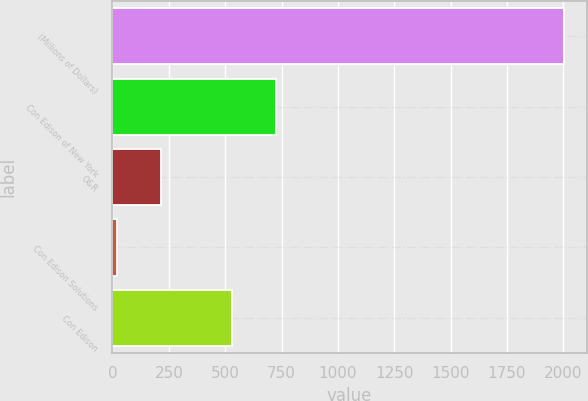<chart> <loc_0><loc_0><loc_500><loc_500><bar_chart><fcel>(Millions of Dollars)<fcel>Con Edison of New York<fcel>O&R<fcel>Con Edison Solutions<fcel>Con Edison<nl><fcel>2003<fcel>726.4<fcel>217.4<fcel>19<fcel>528<nl></chart> 